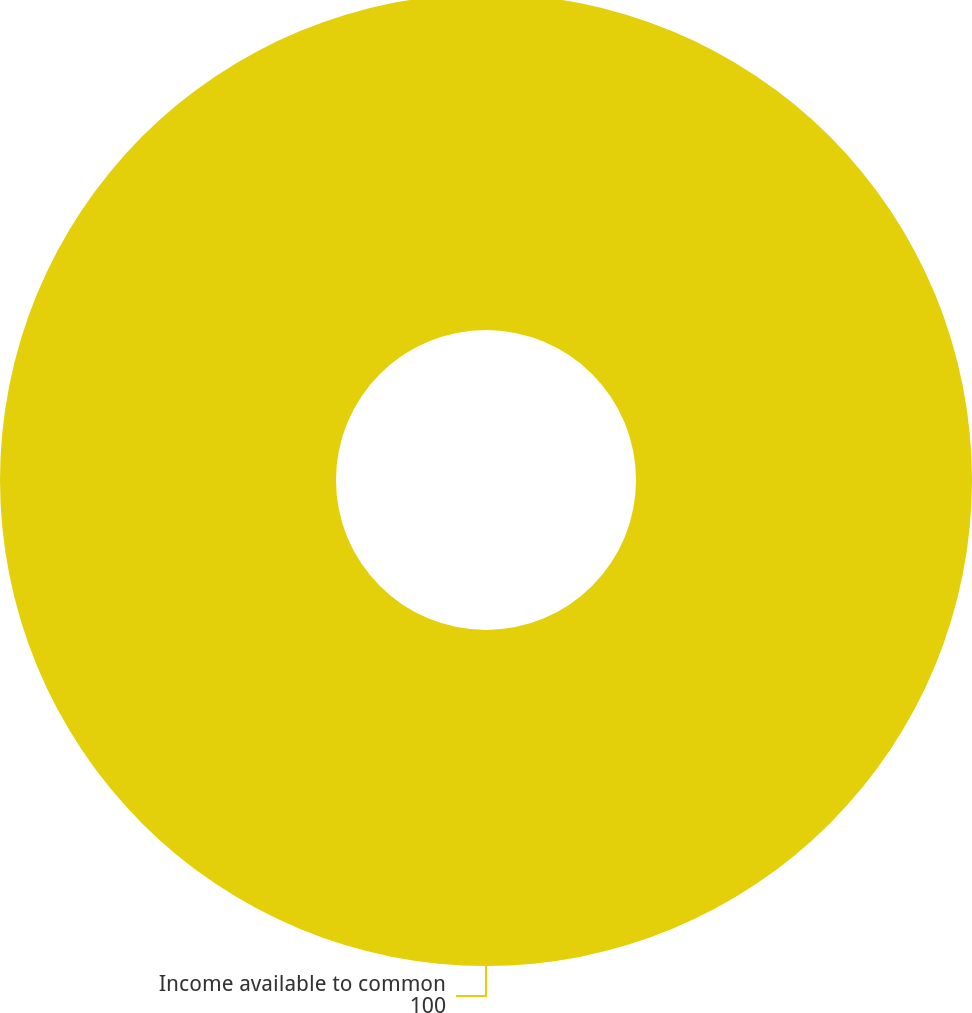Convert chart. <chart><loc_0><loc_0><loc_500><loc_500><pie_chart><fcel>Income available to common<nl><fcel>100.0%<nl></chart> 